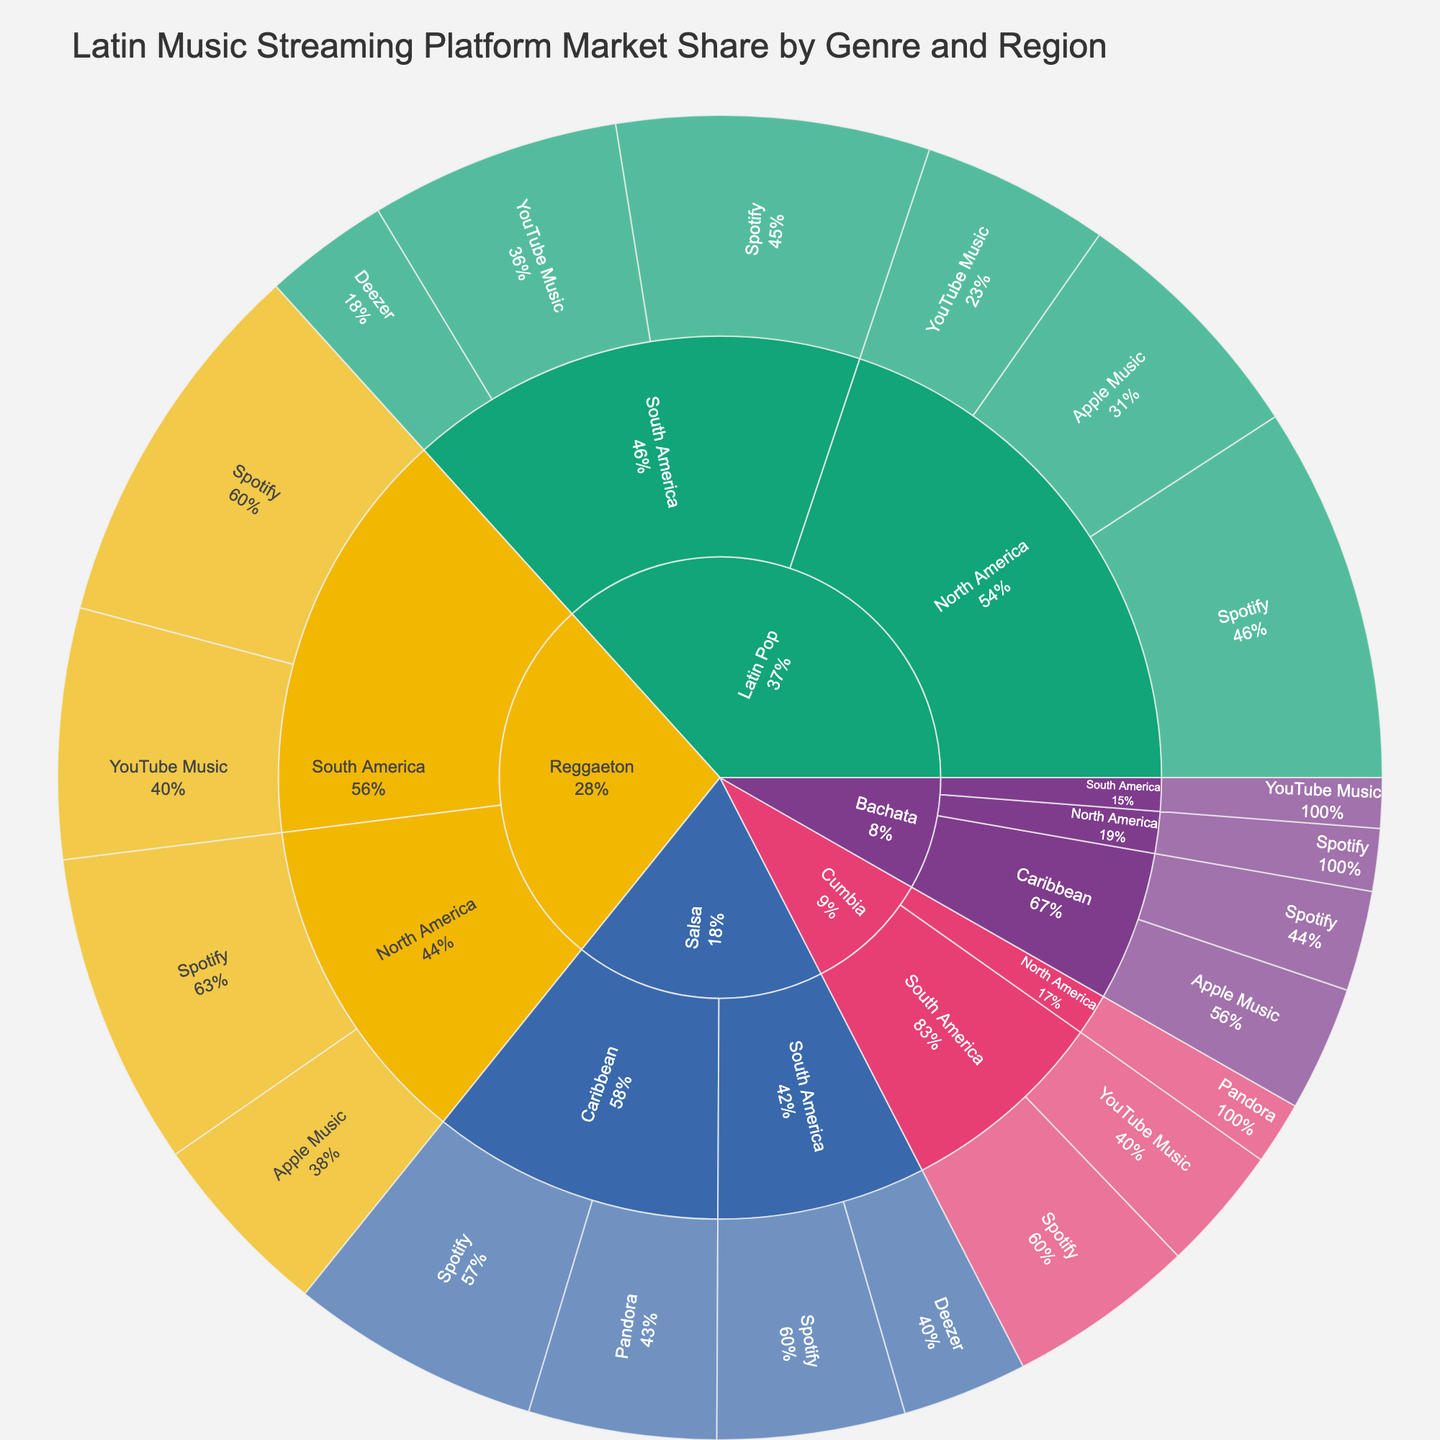What's the title of the plot? The title is usually located at the top of the chart. In this case, it is "Latin Music Streaming Platform Market Share by Genre and Region".
Answer: Latin Music Streaming Platform Market Share by Genre and Region How many main genres are shown in the plot? By observing the top-level divisions of the sunburst plot, we can identify the main genres represented.
Answer: 5 Which genre has the largest market share in South America? By examining the sunburst plot and focusing on the "South America" region, we identify the genre that occupies the largest share.
Answer: Reggaeton What is the sum of the market shares of Spotify in South America for all genres? To calculate the total Spotify share in South America, we add the shares for each genre: Latin Pop (25) + Reggaeton (30) + Salsa (15) + Cumbia (15) = 85.
Answer: 85 Which platform has the smallest market share for Bachata in the Caribbean region? By looking closely at the division of Bachata in the Caribbean region, we identify the platform with the smallest slice.
Answer: Spotify Does Latin Pop have a higher Spotify share in North America or South America? We compare the Spotify shares of Latin Pop between North America (30) and South America (25) and determine which is higher.
Answer: North America What percentage of the total market share is held by Deezer in South America? To determine Deezer's share, we add its shares for genres in South America: Latin Pop (10) + Salsa (10). Combined, it's 20.
Answer: 20 What is the combined market share of Apple Music across all regions? By summing the shares of Apple Music across all regions: Latin Pop North America (20) + Reggaeton North America (15) + Bachata Caribbean (10), we get a total combined share of 45.
Answer: 45 